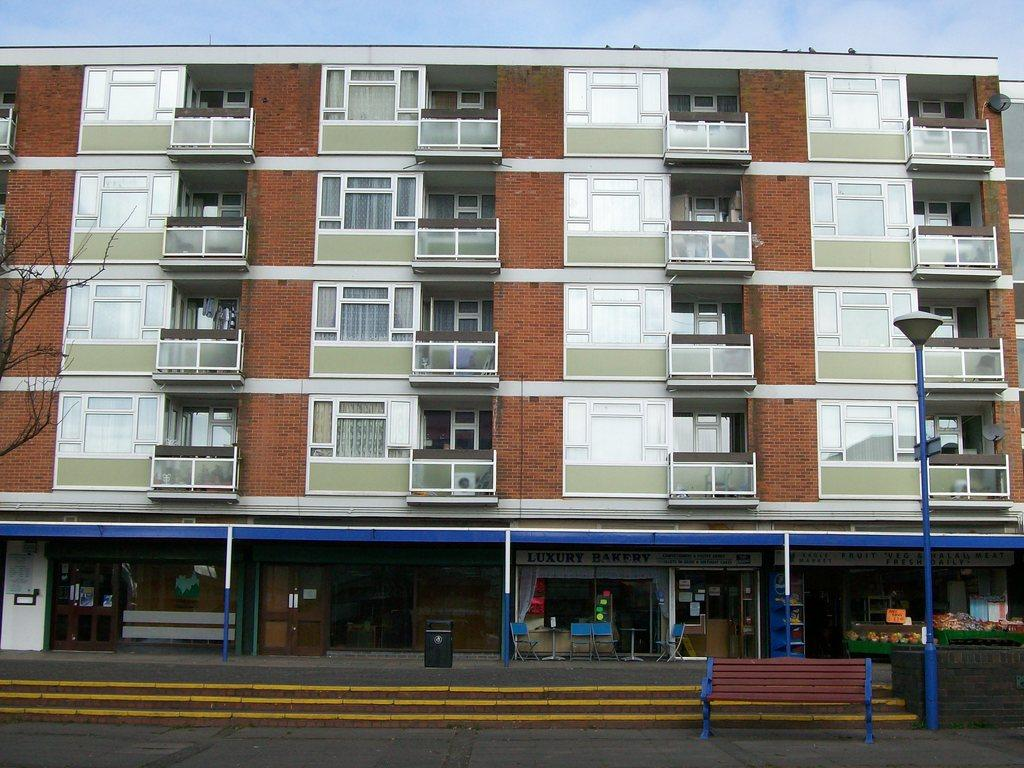What type of structure is present in the image? There is a building in the image. What feature can be seen on the building? There are windows in the building. What cooking appliances are visible in the image? There are grills in the image. Can you describe the arrangement of items in the image? There is an arrangement of items in the image, but the specifics are not mentioned in the facts. What lighting fixture is present in the image? There is a pole with a lamp in the image. What type of cake is being served at the journey in the image? There is no journey or cake present in the image. Can you see any branches in the image? There is no mention of branches in the provided facts, so we cannot determine if any are present in the image. 